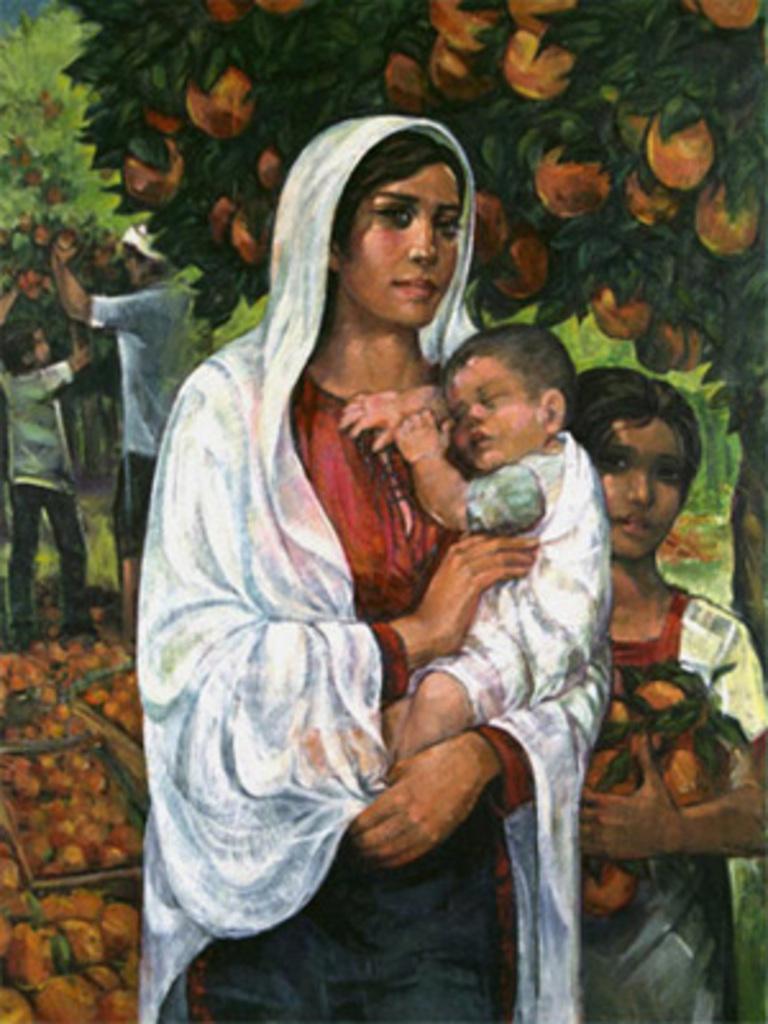In one or two sentences, can you explain what this image depicts? In this image there is a painting. A woman is holding the baby in her arms. Right side there is a person holding fruits. Left side there are people standing on the land having trees. Trees are having fruits and leaves. Left bottom there are baskets having fruits. 